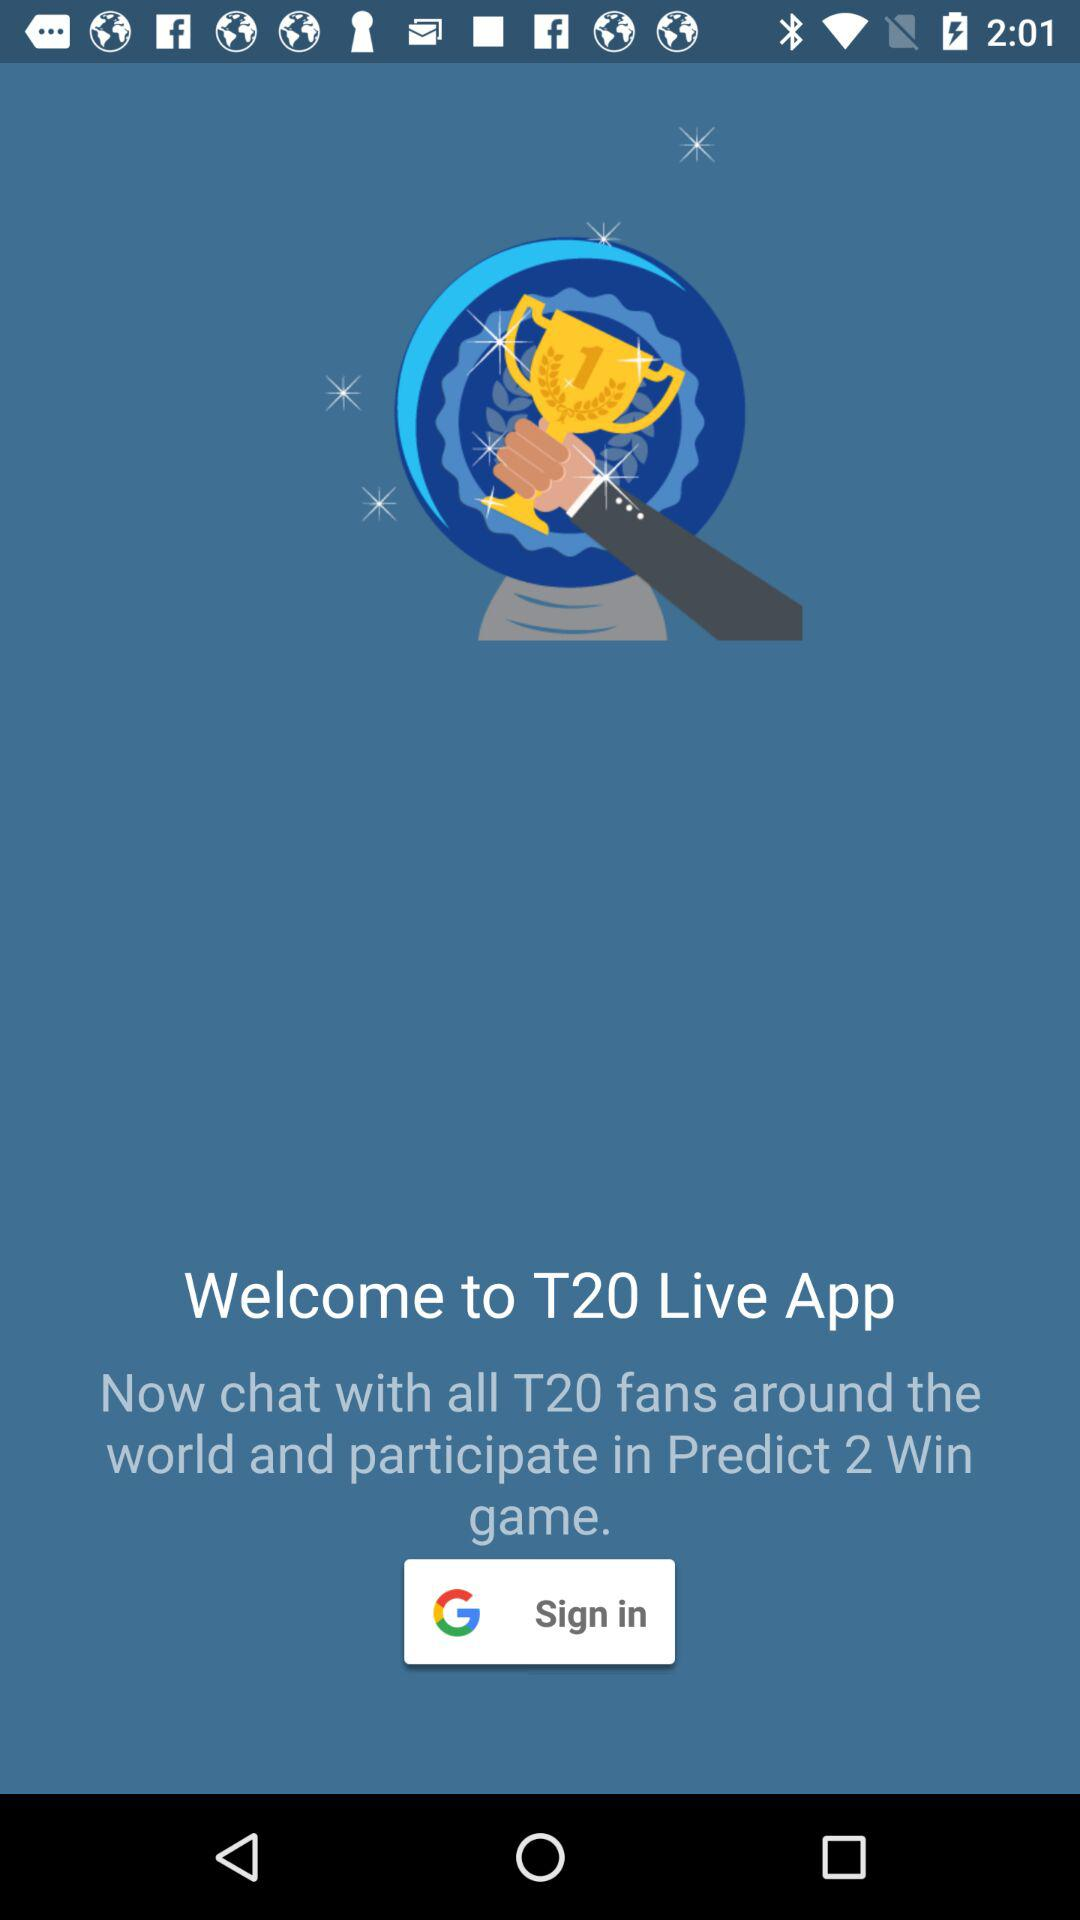What is the app name? The app name is "T20 Live". 